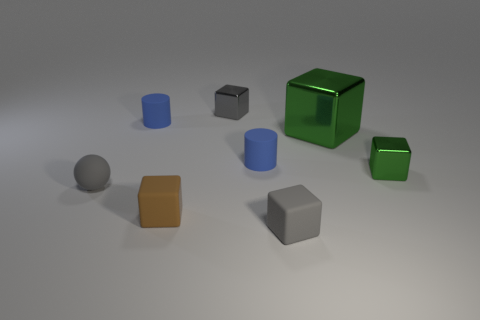Does the matte object in front of the brown matte cube have the same size as the small green block?
Your answer should be very brief. Yes. What is the size of the gray matte block?
Give a very brief answer. Small. Is there a small shiny thing of the same color as the large metallic object?
Provide a succinct answer. Yes. How many large things are green things or red cylinders?
Offer a very short reply. 1. How big is the shiny object that is both behind the tiny green shiny cube and on the right side of the gray matte block?
Give a very brief answer. Large. How many small objects are on the left side of the small green shiny object?
Offer a very short reply. 6. There is a small thing that is both to the right of the small gray sphere and to the left of the brown matte block; what is its shape?
Your answer should be compact. Cylinder. What number of spheres are either big things or metal things?
Your answer should be compact. 0. Is the number of large green metallic things to the left of the tiny gray metallic thing less than the number of matte cylinders?
Provide a succinct answer. Yes. What is the color of the block that is on the left side of the small gray rubber cube and behind the gray matte ball?
Keep it short and to the point. Gray. 